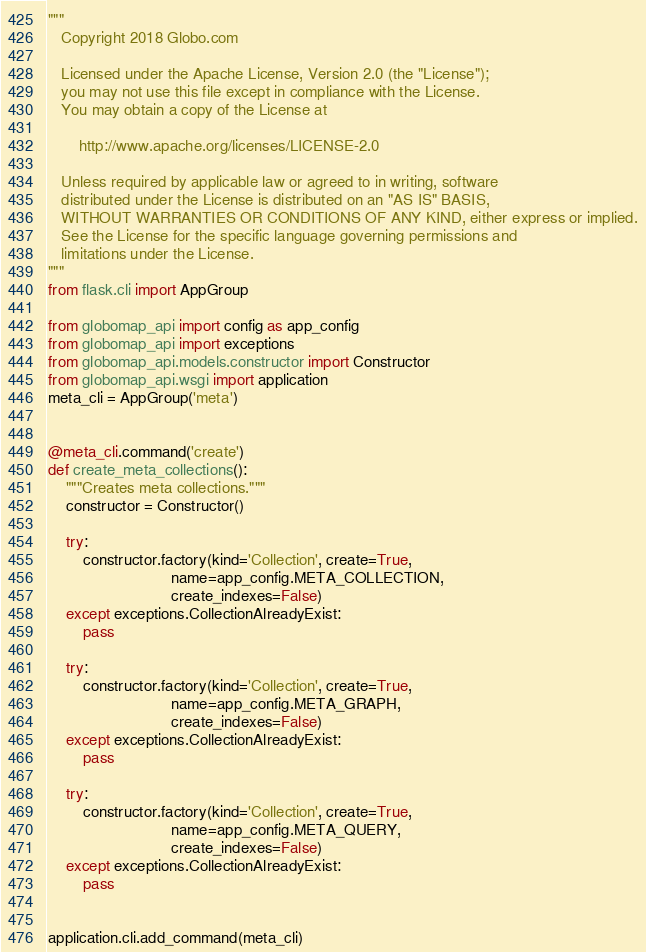<code> <loc_0><loc_0><loc_500><loc_500><_Python_>"""
   Copyright 2018 Globo.com

   Licensed under the Apache License, Version 2.0 (the "License");
   you may not use this file except in compliance with the License.
   You may obtain a copy of the License at

       http://www.apache.org/licenses/LICENSE-2.0

   Unless required by applicable law or agreed to in writing, software
   distributed under the License is distributed on an "AS IS" BASIS,
   WITHOUT WARRANTIES OR CONDITIONS OF ANY KIND, either express or implied.
   See the License for the specific language governing permissions and
   limitations under the License.
"""
from flask.cli import AppGroup

from globomap_api import config as app_config
from globomap_api import exceptions
from globomap_api.models.constructor import Constructor
from globomap_api.wsgi import application
meta_cli = AppGroup('meta')


@meta_cli.command('create')
def create_meta_collections():
    """Creates meta collections."""
    constructor = Constructor()

    try:
        constructor.factory(kind='Collection', create=True,
                            name=app_config.META_COLLECTION,
                            create_indexes=False)
    except exceptions.CollectionAlreadyExist:
        pass

    try:
        constructor.factory(kind='Collection', create=True,
                            name=app_config.META_GRAPH,
                            create_indexes=False)
    except exceptions.CollectionAlreadyExist:
        pass

    try:
        constructor.factory(kind='Collection', create=True,
                            name=app_config.META_QUERY,
                            create_indexes=False)
    except exceptions.CollectionAlreadyExist:
        pass


application.cli.add_command(meta_cli)
</code> 